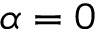<formula> <loc_0><loc_0><loc_500><loc_500>\alpha = 0</formula> 